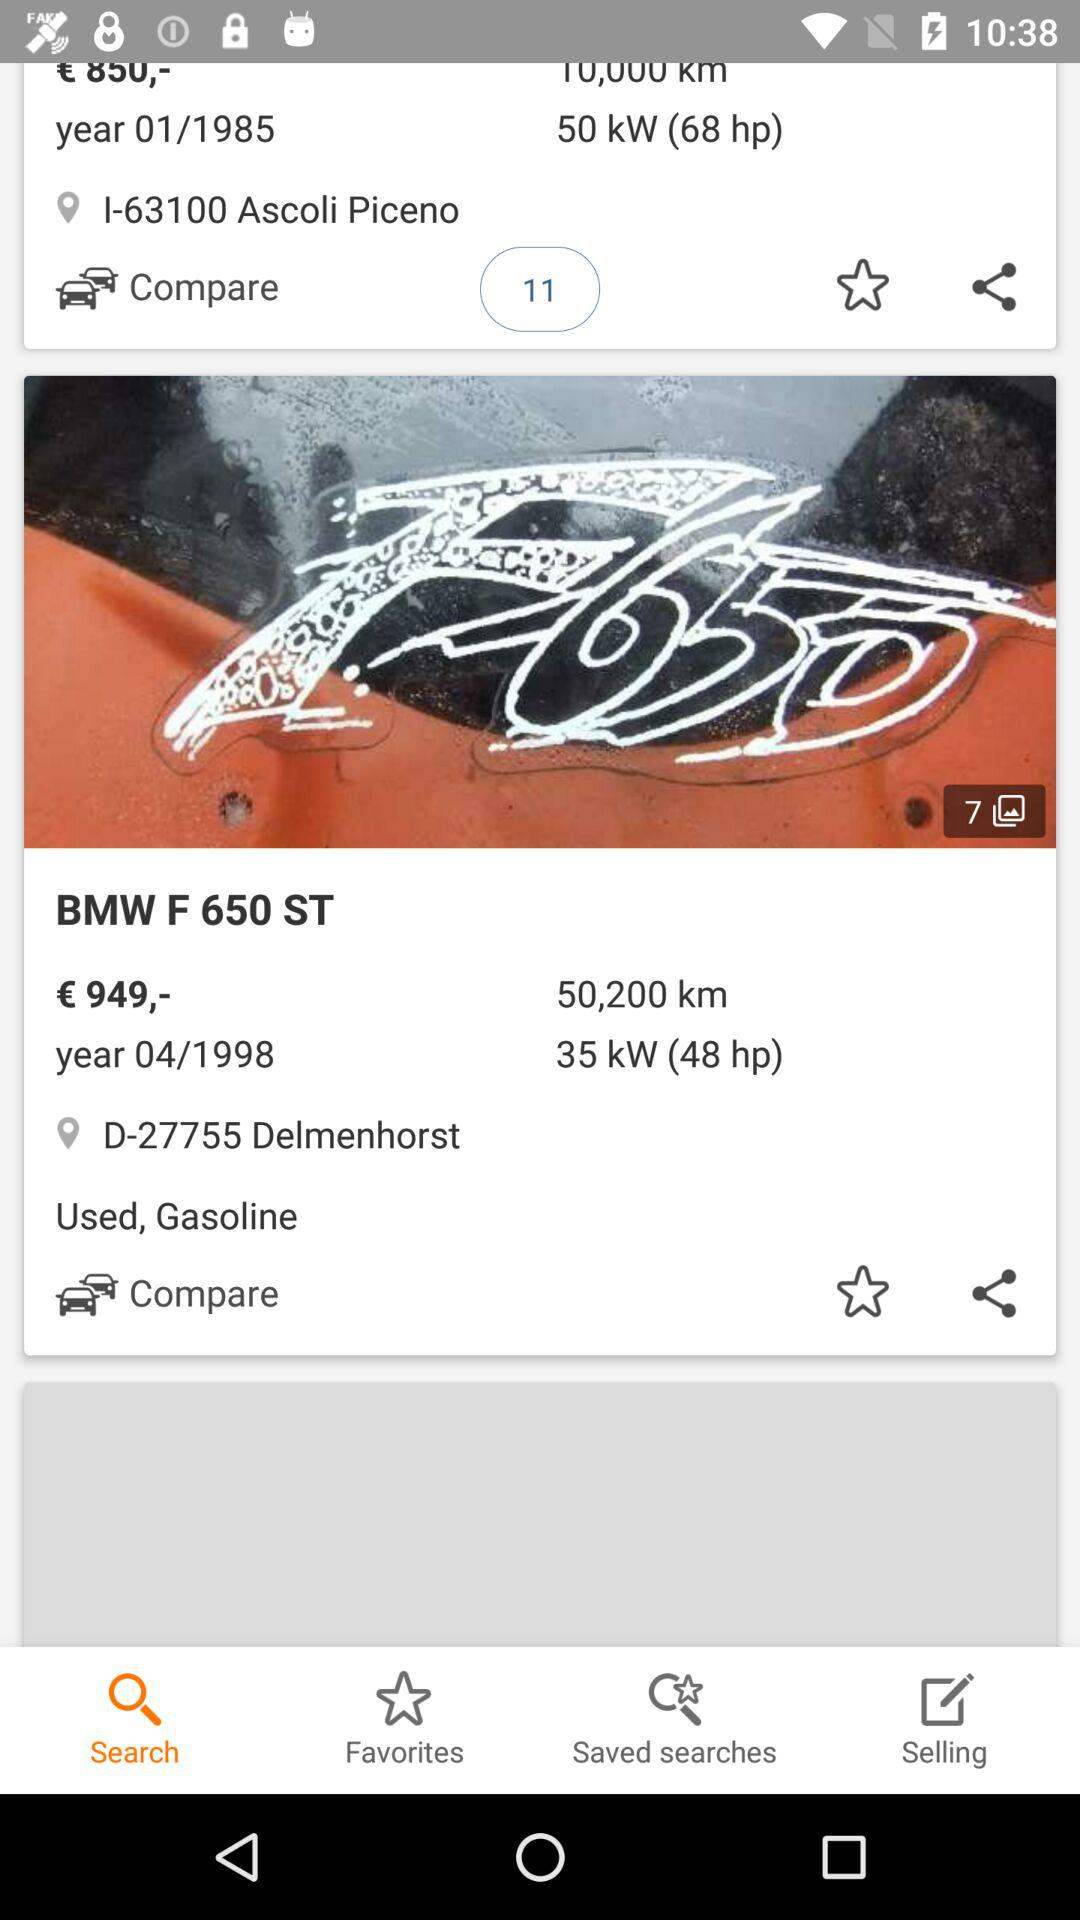What is the model of the vehicle? The model of the vehicle is "F 650 ST". 